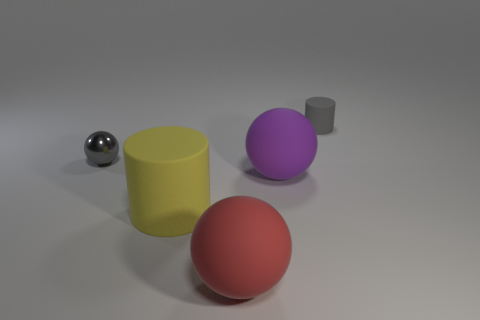Subtract all large purple balls. How many balls are left? 2 Subtract all gray balls. How many balls are left? 2 Subtract all spheres. How many objects are left? 2 Subtract all large gray things. Subtract all large red things. How many objects are left? 4 Add 5 large purple objects. How many large purple objects are left? 6 Add 5 large things. How many large things exist? 8 Add 5 brown cylinders. How many objects exist? 10 Subtract 0 red cubes. How many objects are left? 5 Subtract all blue balls. Subtract all brown blocks. How many balls are left? 3 Subtract all blue cubes. How many red spheres are left? 1 